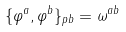Convert formula to latex. <formula><loc_0><loc_0><loc_500><loc_500>\{ \varphi ^ { a } , \varphi ^ { b } \} _ { p b } = \omega ^ { a b }</formula> 